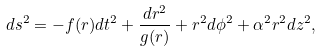Convert formula to latex. <formula><loc_0><loc_0><loc_500><loc_500>d s ^ { 2 } = - f ( r ) d t ^ { 2 } + \frac { d r ^ { 2 } } { g ( r ) } + r ^ { 2 } d \phi ^ { 2 } + \alpha ^ { 2 } r ^ { 2 } d z ^ { 2 } ,</formula> 